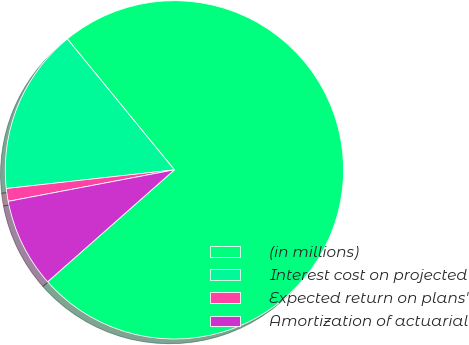<chart> <loc_0><loc_0><loc_500><loc_500><pie_chart><fcel>(in millions)<fcel>Interest cost on projected<fcel>Expected return on plans'<fcel>Amortization of actuarial<nl><fcel>74.4%<fcel>15.85%<fcel>1.22%<fcel>8.53%<nl></chart> 